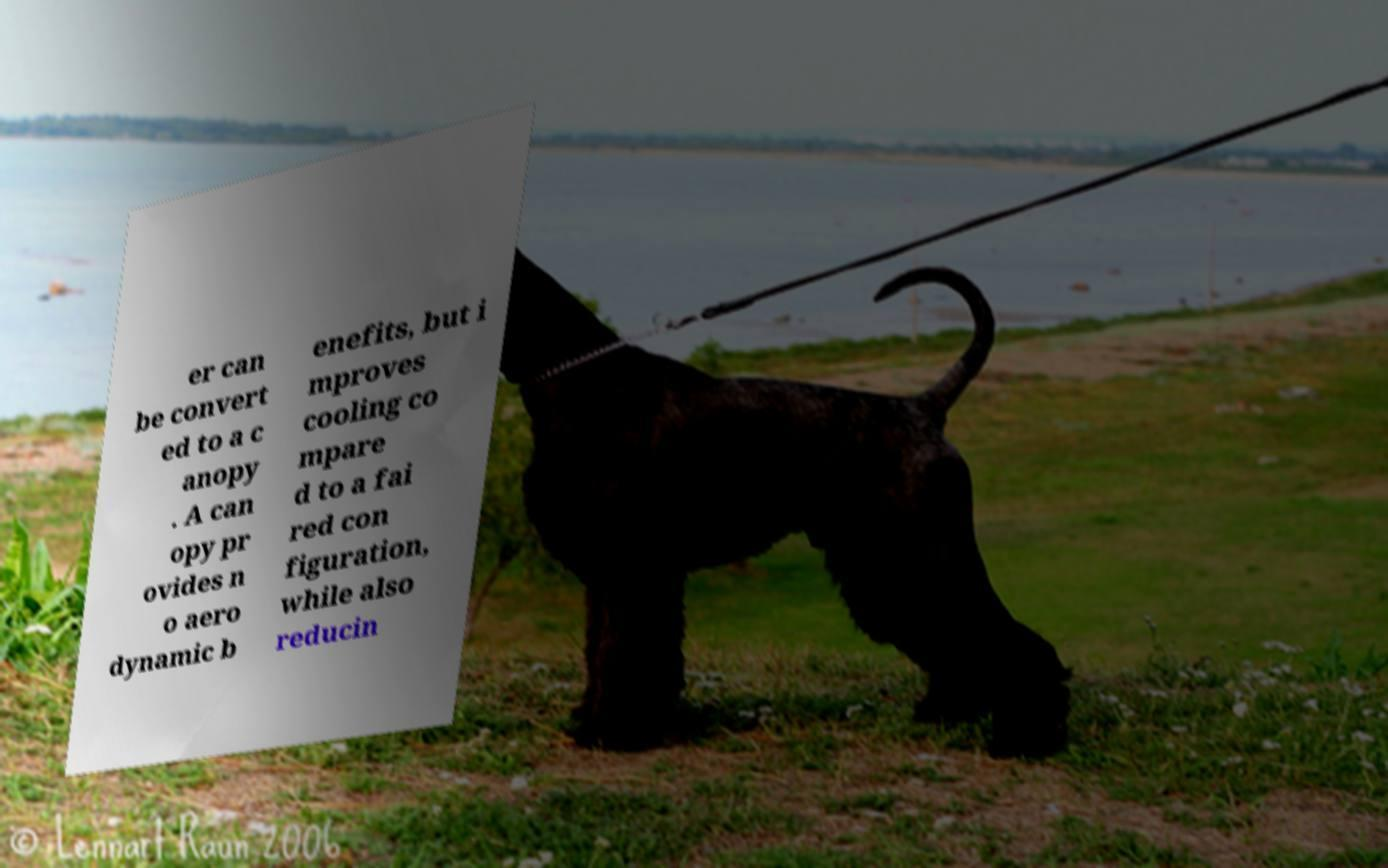Could you assist in decoding the text presented in this image and type it out clearly? er can be convert ed to a c anopy . A can opy pr ovides n o aero dynamic b enefits, but i mproves cooling co mpare d to a fai red con figuration, while also reducin 